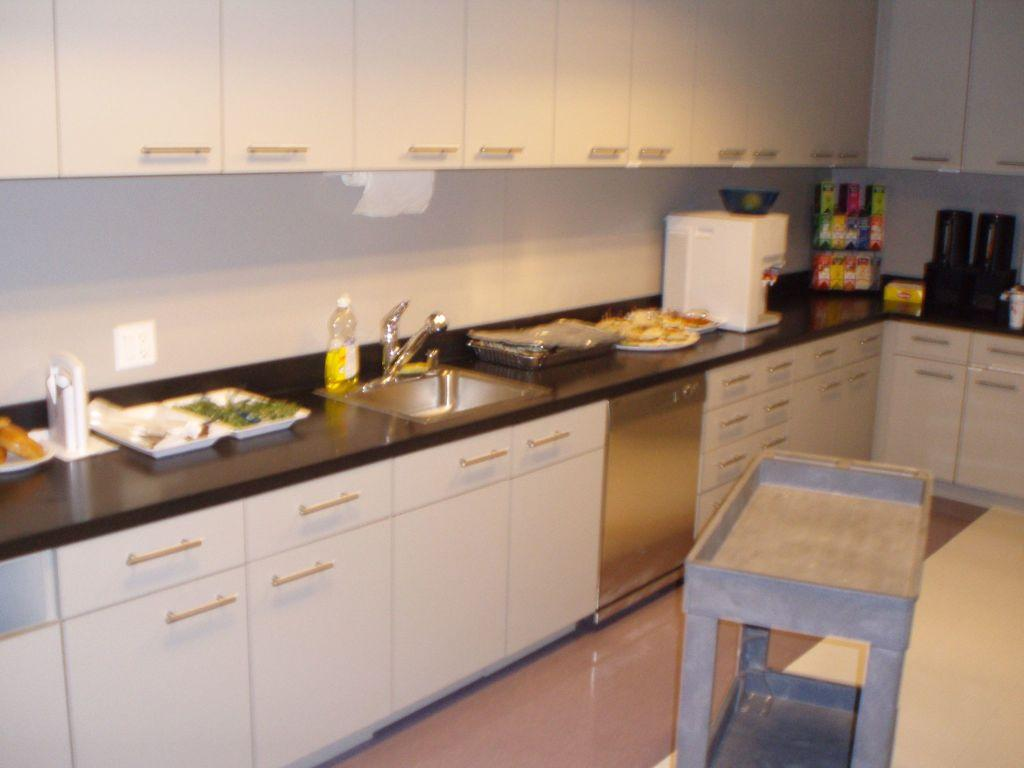What type of furniture is present in the image? There are cupboards in the image. What can be found near the cupboards? There is a sink in the image. What is attached to the sink? There is a tap in the image. What items are visible on the surface near the sink? There are plates and a bottle in the image. What is the surface made of that the items are placed on? There is a floor visible in the image. What type of food can be seen in the image? There is food in the image. What else is present in the image besides the mentioned items? There are objects in the image. Can you see any smoke coming from the rifle in the image? There is no rifle or smoke present in the image. What type of trade is being conducted in the image? There is no trade or any indication of a transaction taking place in the image. 